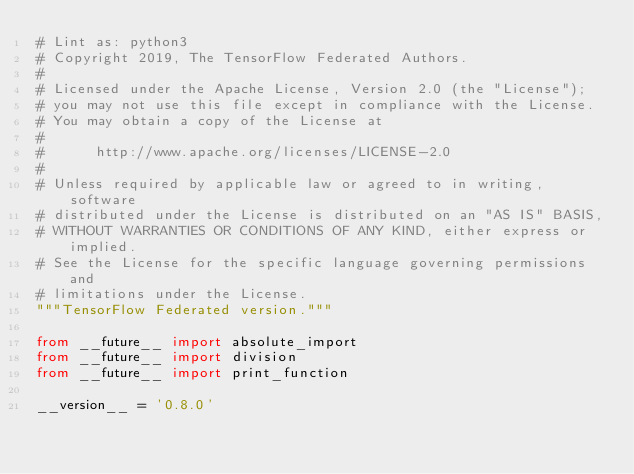Convert code to text. <code><loc_0><loc_0><loc_500><loc_500><_Python_># Lint as: python3
# Copyright 2019, The TensorFlow Federated Authors.
#
# Licensed under the Apache License, Version 2.0 (the "License");
# you may not use this file except in compliance with the License.
# You may obtain a copy of the License at
#
#      http://www.apache.org/licenses/LICENSE-2.0
#
# Unless required by applicable law or agreed to in writing, software
# distributed under the License is distributed on an "AS IS" BASIS,
# WITHOUT WARRANTIES OR CONDITIONS OF ANY KIND, either express or implied.
# See the License for the specific language governing permissions and
# limitations under the License.
"""TensorFlow Federated version."""

from __future__ import absolute_import
from __future__ import division
from __future__ import print_function

__version__ = '0.8.0'
</code> 